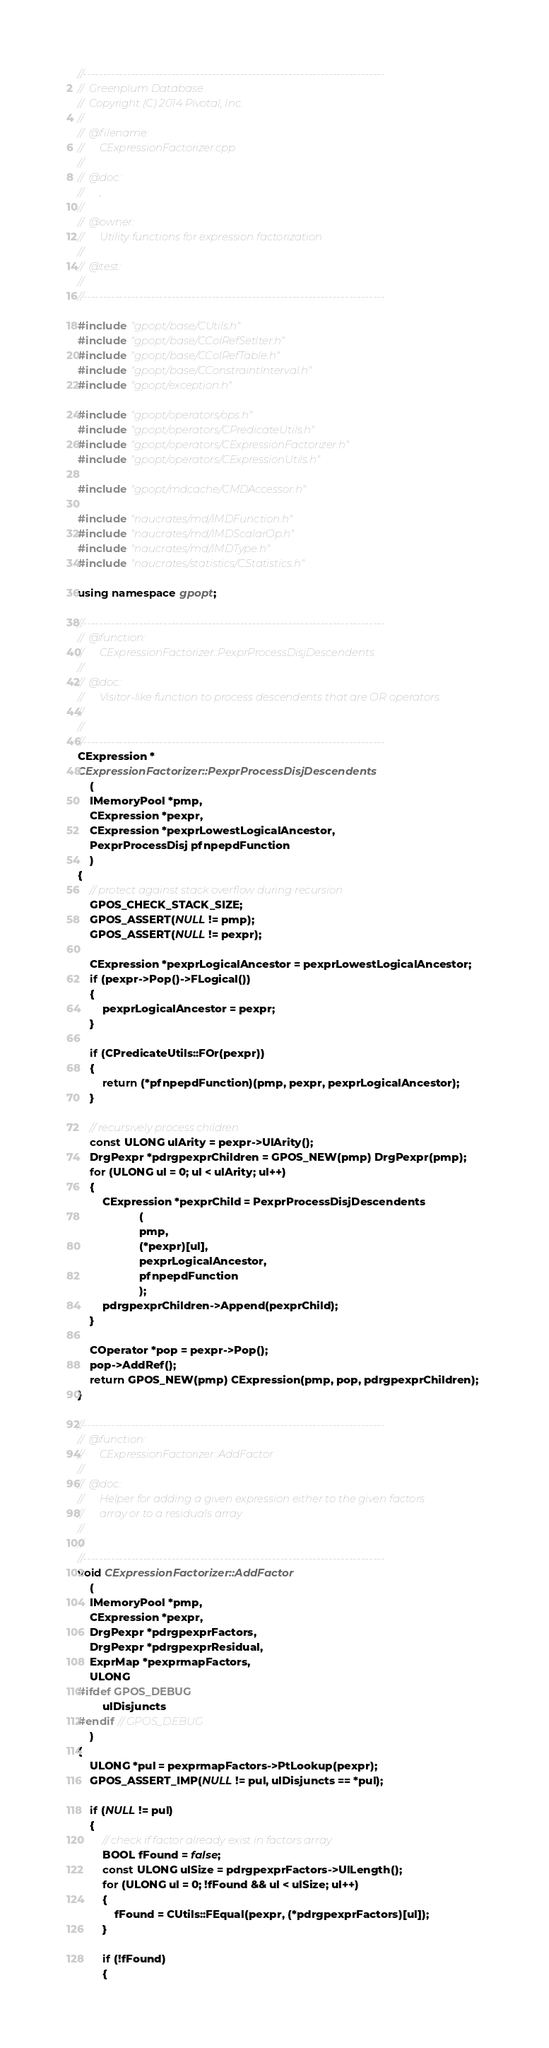<code> <loc_0><loc_0><loc_500><loc_500><_C++_>//---------------------------------------------------------------------------
//	Greenplum Database
//	Copyright (C) 2014 Pivotal, Inc.
//
//	@filename:
//		CExpressionFactorizer.cpp
//
//	@doc:
//		, 
//
//	@owner:
//		Utility functions for expression factorization
//
//	@test:
//
//---------------------------------------------------------------------------

#include "gpopt/base/CUtils.h"
#include "gpopt/base/CColRefSetIter.h"
#include "gpopt/base/CColRefTable.h"
#include "gpopt/base/CConstraintInterval.h"
#include "gpopt/exception.h"

#include "gpopt/operators/ops.h"
#include "gpopt/operators/CPredicateUtils.h"
#include "gpopt/operators/CExpressionFactorizer.h"
#include "gpopt/operators/CExpressionUtils.h"

#include "gpopt/mdcache/CMDAccessor.h"

#include "naucrates/md/IMDFunction.h"
#include "naucrates/md/IMDScalarOp.h"
#include "naucrates/md/IMDType.h"
#include "naucrates/statistics/CStatistics.h"

using namespace gpopt;

//---------------------------------------------------------------------------
//	@function:
//		CExpressionFactorizer::PexprProcessDisjDescendents
//
//	@doc:
//		Visitor-like function to process descendents that are OR operators.
//
//
//---------------------------------------------------------------------------
CExpression *
CExpressionFactorizer::PexprProcessDisjDescendents
	(
	IMemoryPool *pmp,
	CExpression *pexpr,
	CExpression *pexprLowestLogicalAncestor,
	PexprProcessDisj pfnpepdFunction
	)
{
	// protect against stack overflow during recursion
	GPOS_CHECK_STACK_SIZE;
	GPOS_ASSERT(NULL != pmp);
	GPOS_ASSERT(NULL != pexpr);

	CExpression *pexprLogicalAncestor = pexprLowestLogicalAncestor;
	if (pexpr->Pop()->FLogical())
	{
		pexprLogicalAncestor = pexpr;
	}

	if (CPredicateUtils::FOr(pexpr))
	{
		return (*pfnpepdFunction)(pmp, pexpr, pexprLogicalAncestor);
	}

	// recursively process children
	const ULONG ulArity = pexpr->UlArity();
	DrgPexpr *pdrgpexprChildren = GPOS_NEW(pmp) DrgPexpr(pmp);
	for (ULONG ul = 0; ul < ulArity; ul++)
	{
		CExpression *pexprChild = PexprProcessDisjDescendents
					(
					pmp,
					(*pexpr)[ul],
					pexprLogicalAncestor,
					pfnpepdFunction
					);
		pdrgpexprChildren->Append(pexprChild);
	}

	COperator *pop = pexpr->Pop();
	pop->AddRef();
	return GPOS_NEW(pmp) CExpression(pmp, pop, pdrgpexprChildren);
}

//---------------------------------------------------------------------------
//	@function:
//		CExpressionFactorizer::AddFactor
//
//	@doc:
//		Helper for adding a given expression either to the given factors
//		array or to a residuals array
//
//
//---------------------------------------------------------------------------
void CExpressionFactorizer::AddFactor
	(
	IMemoryPool *pmp,
	CExpression *pexpr,
	DrgPexpr *pdrgpexprFactors,
	DrgPexpr *pdrgpexprResidual,
	ExprMap *pexprmapFactors,
	ULONG
#ifdef GPOS_DEBUG
		ulDisjuncts
#endif // GPOS_DEBUG
	)
{
	ULONG *pul = pexprmapFactors->PtLookup(pexpr);
	GPOS_ASSERT_IMP(NULL != pul, ulDisjuncts == *pul);

	if (NULL != pul)
	{
		// check if factor already exist in factors array
		BOOL fFound = false;
		const ULONG ulSize = pdrgpexprFactors->UlLength();
		for (ULONG ul = 0; !fFound && ul < ulSize; ul++)
		{
			fFound = CUtils::FEqual(pexpr, (*pdrgpexprFactors)[ul]);
		}

		if (!fFound)
		{</code> 